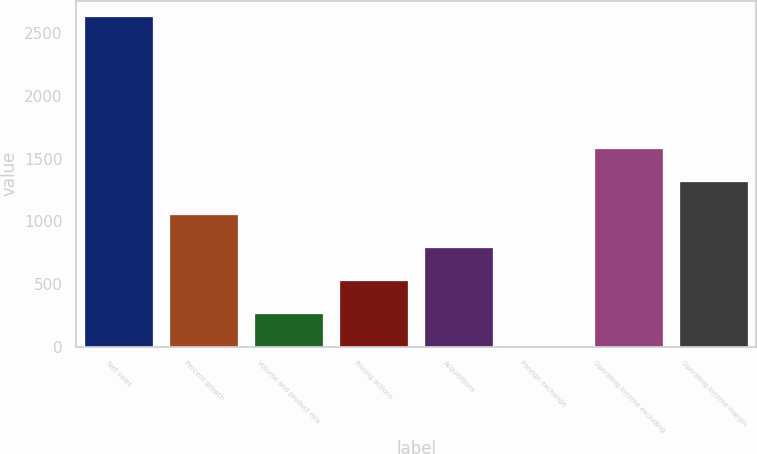Convert chart to OTSL. <chart><loc_0><loc_0><loc_500><loc_500><bar_chart><fcel>Net sales<fcel>Percent growth<fcel>Volume and product mix<fcel>Pricing actions<fcel>Acquisitions<fcel>Foreign exchange<fcel>Operating income excluding<fcel>Operating income margin<nl><fcel>2625.5<fcel>1050.44<fcel>262.91<fcel>525.42<fcel>787.93<fcel>0.4<fcel>1575.46<fcel>1312.95<nl></chart> 